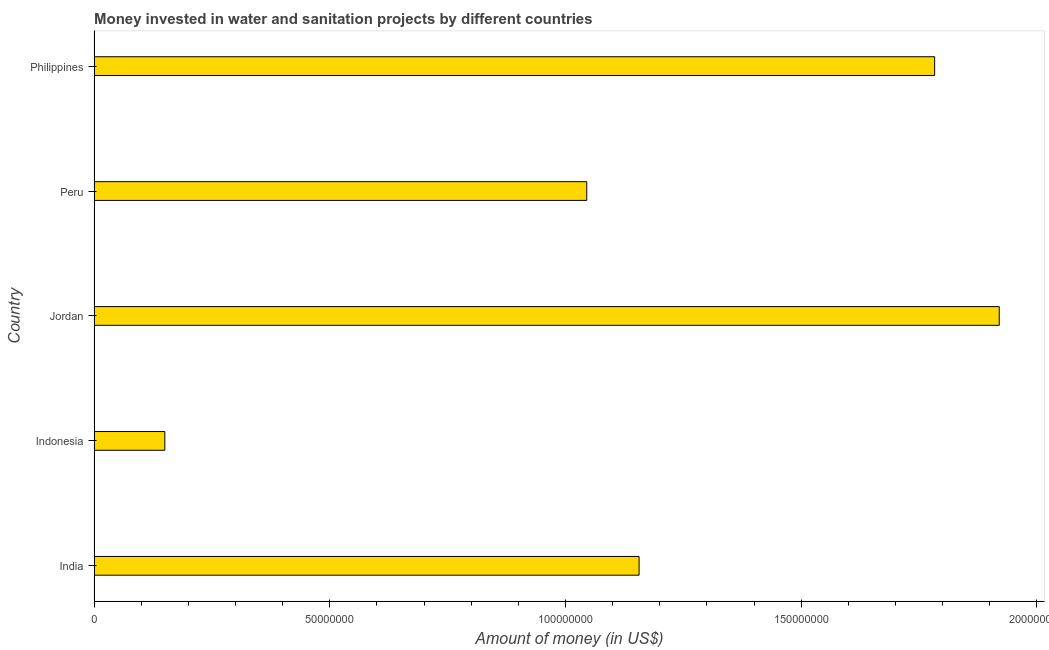What is the title of the graph?
Offer a very short reply. Money invested in water and sanitation projects by different countries. What is the label or title of the X-axis?
Provide a short and direct response. Amount of money (in US$). What is the investment in Indonesia?
Provide a succinct answer. 1.50e+07. Across all countries, what is the maximum investment?
Provide a succinct answer. 1.92e+08. Across all countries, what is the minimum investment?
Keep it short and to the point. 1.50e+07. In which country was the investment maximum?
Give a very brief answer. Jordan. What is the sum of the investment?
Give a very brief answer. 6.05e+08. What is the difference between the investment in Peru and Philippines?
Keep it short and to the point. -7.38e+07. What is the average investment per country?
Offer a very short reply. 1.21e+08. What is the median investment?
Your answer should be very brief. 1.16e+08. In how many countries, is the investment greater than 60000000 US$?
Provide a succinct answer. 4. What is the ratio of the investment in Indonesia to that in Peru?
Offer a very short reply. 0.14. Is the investment in Indonesia less than that in Peru?
Give a very brief answer. Yes. Is the difference between the investment in Indonesia and Jordan greater than the difference between any two countries?
Ensure brevity in your answer.  Yes. What is the difference between the highest and the second highest investment?
Give a very brief answer. 1.37e+07. Is the sum of the investment in India and Philippines greater than the maximum investment across all countries?
Your response must be concise. Yes. What is the difference between the highest and the lowest investment?
Make the answer very short. 1.77e+08. Are all the bars in the graph horizontal?
Provide a succinct answer. Yes. How many countries are there in the graph?
Provide a short and direct response. 5. Are the values on the major ticks of X-axis written in scientific E-notation?
Your response must be concise. No. What is the Amount of money (in US$) in India?
Keep it short and to the point. 1.16e+08. What is the Amount of money (in US$) in Indonesia?
Offer a terse response. 1.50e+07. What is the Amount of money (in US$) in Jordan?
Your response must be concise. 1.92e+08. What is the Amount of money (in US$) in Peru?
Offer a terse response. 1.04e+08. What is the Amount of money (in US$) of Philippines?
Your response must be concise. 1.78e+08. What is the difference between the Amount of money (in US$) in India and Indonesia?
Offer a terse response. 1.01e+08. What is the difference between the Amount of money (in US$) in India and Jordan?
Ensure brevity in your answer.  -7.64e+07. What is the difference between the Amount of money (in US$) in India and Peru?
Make the answer very short. 1.11e+07. What is the difference between the Amount of money (in US$) in India and Philippines?
Ensure brevity in your answer.  -6.27e+07. What is the difference between the Amount of money (in US$) in Indonesia and Jordan?
Your answer should be compact. -1.77e+08. What is the difference between the Amount of money (in US$) in Indonesia and Peru?
Your response must be concise. -8.95e+07. What is the difference between the Amount of money (in US$) in Indonesia and Philippines?
Provide a succinct answer. -1.63e+08. What is the difference between the Amount of money (in US$) in Jordan and Peru?
Your answer should be compact. 8.75e+07. What is the difference between the Amount of money (in US$) in Jordan and Philippines?
Ensure brevity in your answer.  1.37e+07. What is the difference between the Amount of money (in US$) in Peru and Philippines?
Provide a short and direct response. -7.38e+07. What is the ratio of the Amount of money (in US$) in India to that in Indonesia?
Your response must be concise. 7.71. What is the ratio of the Amount of money (in US$) in India to that in Jordan?
Your answer should be very brief. 0.6. What is the ratio of the Amount of money (in US$) in India to that in Peru?
Ensure brevity in your answer.  1.11. What is the ratio of the Amount of money (in US$) in India to that in Philippines?
Give a very brief answer. 0.65. What is the ratio of the Amount of money (in US$) in Indonesia to that in Jordan?
Keep it short and to the point. 0.08. What is the ratio of the Amount of money (in US$) in Indonesia to that in Peru?
Provide a short and direct response. 0.14. What is the ratio of the Amount of money (in US$) in Indonesia to that in Philippines?
Give a very brief answer. 0.08. What is the ratio of the Amount of money (in US$) in Jordan to that in Peru?
Provide a short and direct response. 1.84. What is the ratio of the Amount of money (in US$) in Jordan to that in Philippines?
Your answer should be compact. 1.08. What is the ratio of the Amount of money (in US$) in Peru to that in Philippines?
Provide a short and direct response. 0.59. 